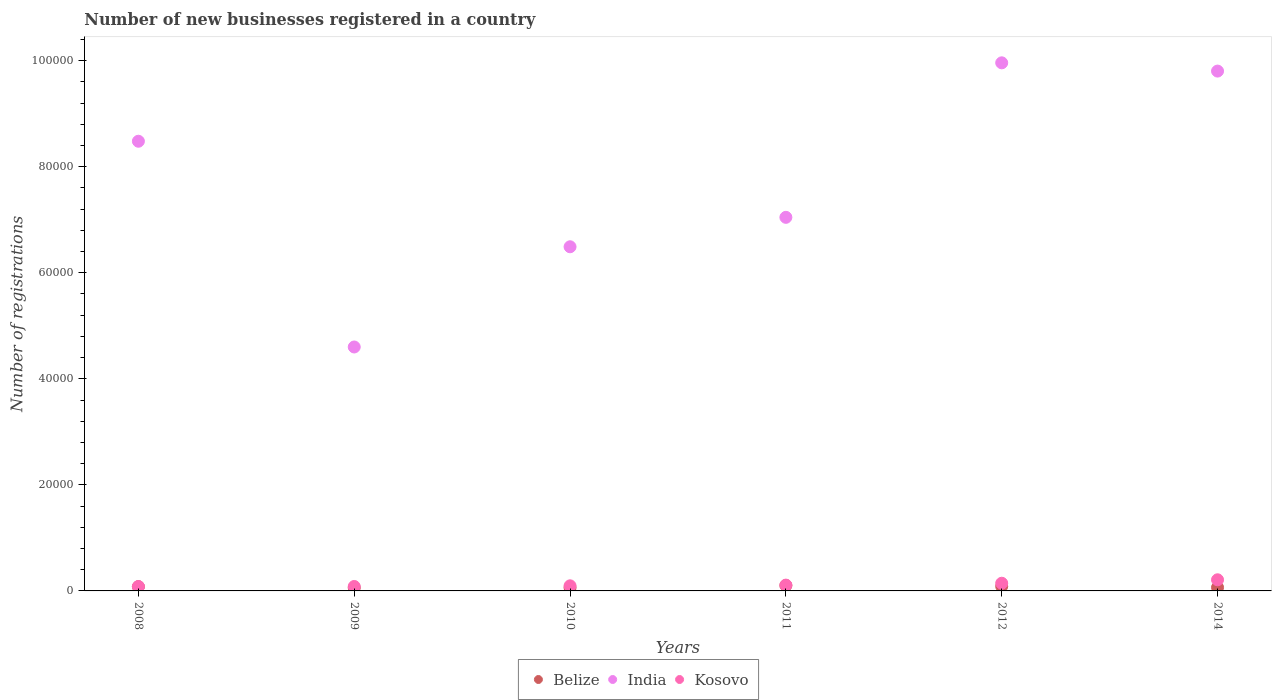What is the number of new businesses registered in India in 2012?
Provide a short and direct response. 9.96e+04. Across all years, what is the maximum number of new businesses registered in Belize?
Keep it short and to the point. 1025. Across all years, what is the minimum number of new businesses registered in India?
Offer a terse response. 4.60e+04. In which year was the number of new businesses registered in Kosovo maximum?
Keep it short and to the point. 2014. In which year was the number of new businesses registered in Kosovo minimum?
Offer a terse response. 2008. What is the total number of new businesses registered in Kosovo in the graph?
Your response must be concise. 7271. What is the difference between the number of new businesses registered in Belize in 2008 and that in 2014?
Provide a succinct answer. 146. What is the difference between the number of new businesses registered in India in 2008 and the number of new businesses registered in Belize in 2009?
Your answer should be compact. 8.42e+04. What is the average number of new businesses registered in Belize per year?
Ensure brevity in your answer.  754.17. In the year 2009, what is the difference between the number of new businesses registered in India and number of new businesses registered in Belize?
Offer a terse response. 4.54e+04. What is the ratio of the number of new businesses registered in India in 2009 to that in 2012?
Ensure brevity in your answer.  0.46. What is the difference between the highest and the second highest number of new businesses registered in Belize?
Keep it short and to the point. 163. What is the difference between the highest and the lowest number of new businesses registered in Belize?
Offer a terse response. 444. In how many years, is the number of new businesses registered in India greater than the average number of new businesses registered in India taken over all years?
Offer a very short reply. 3. Is the sum of the number of new businesses registered in Kosovo in 2008 and 2014 greater than the maximum number of new businesses registered in Belize across all years?
Your answer should be compact. Yes. How many years are there in the graph?
Your answer should be very brief. 6. Does the graph contain any zero values?
Offer a very short reply. No. What is the title of the graph?
Ensure brevity in your answer.  Number of new businesses registered in a country. What is the label or title of the Y-axis?
Make the answer very short. Number of registrations. What is the Number of registrations of Belize in 2008?
Provide a succinct answer. 801. What is the Number of registrations of India in 2008?
Ensure brevity in your answer.  8.48e+04. What is the Number of registrations of Kosovo in 2008?
Your answer should be very brief. 829. What is the Number of registrations of Belize in 2009?
Give a very brief answer. 581. What is the Number of registrations in India in 2009?
Keep it short and to the point. 4.60e+04. What is the Number of registrations in Kosovo in 2009?
Keep it short and to the point. 836. What is the Number of registrations of Belize in 2010?
Your response must be concise. 601. What is the Number of registrations in India in 2010?
Keep it short and to the point. 6.49e+04. What is the Number of registrations of Kosovo in 2010?
Offer a very short reply. 962. What is the Number of registrations of Belize in 2011?
Make the answer very short. 1025. What is the Number of registrations in India in 2011?
Give a very brief answer. 7.04e+04. What is the Number of registrations of Kosovo in 2011?
Make the answer very short. 1095. What is the Number of registrations in Belize in 2012?
Offer a terse response. 862. What is the Number of registrations in India in 2012?
Provide a short and direct response. 9.96e+04. What is the Number of registrations in Kosovo in 2012?
Keep it short and to the point. 1449. What is the Number of registrations in Belize in 2014?
Your response must be concise. 655. What is the Number of registrations of India in 2014?
Give a very brief answer. 9.80e+04. What is the Number of registrations in Kosovo in 2014?
Keep it short and to the point. 2100. Across all years, what is the maximum Number of registrations in Belize?
Make the answer very short. 1025. Across all years, what is the maximum Number of registrations of India?
Provide a succinct answer. 9.96e+04. Across all years, what is the maximum Number of registrations of Kosovo?
Your response must be concise. 2100. Across all years, what is the minimum Number of registrations in Belize?
Your response must be concise. 581. Across all years, what is the minimum Number of registrations of India?
Give a very brief answer. 4.60e+04. Across all years, what is the minimum Number of registrations of Kosovo?
Your answer should be very brief. 829. What is the total Number of registrations in Belize in the graph?
Provide a succinct answer. 4525. What is the total Number of registrations of India in the graph?
Give a very brief answer. 4.64e+05. What is the total Number of registrations of Kosovo in the graph?
Provide a short and direct response. 7271. What is the difference between the Number of registrations in Belize in 2008 and that in 2009?
Keep it short and to the point. 220. What is the difference between the Number of registrations of India in 2008 and that in 2009?
Offer a terse response. 3.88e+04. What is the difference between the Number of registrations of India in 2008 and that in 2010?
Provide a succinct answer. 1.99e+04. What is the difference between the Number of registrations in Kosovo in 2008 and that in 2010?
Offer a very short reply. -133. What is the difference between the Number of registrations of Belize in 2008 and that in 2011?
Provide a succinct answer. -224. What is the difference between the Number of registrations in India in 2008 and that in 2011?
Keep it short and to the point. 1.44e+04. What is the difference between the Number of registrations in Kosovo in 2008 and that in 2011?
Ensure brevity in your answer.  -266. What is the difference between the Number of registrations in Belize in 2008 and that in 2012?
Your response must be concise. -61. What is the difference between the Number of registrations in India in 2008 and that in 2012?
Give a very brief answer. -1.48e+04. What is the difference between the Number of registrations in Kosovo in 2008 and that in 2012?
Provide a short and direct response. -620. What is the difference between the Number of registrations in Belize in 2008 and that in 2014?
Give a very brief answer. 146. What is the difference between the Number of registrations in India in 2008 and that in 2014?
Offer a very short reply. -1.32e+04. What is the difference between the Number of registrations in Kosovo in 2008 and that in 2014?
Keep it short and to the point. -1271. What is the difference between the Number of registrations in India in 2009 and that in 2010?
Your response must be concise. -1.89e+04. What is the difference between the Number of registrations of Kosovo in 2009 and that in 2010?
Keep it short and to the point. -126. What is the difference between the Number of registrations of Belize in 2009 and that in 2011?
Offer a very short reply. -444. What is the difference between the Number of registrations in India in 2009 and that in 2011?
Your response must be concise. -2.44e+04. What is the difference between the Number of registrations of Kosovo in 2009 and that in 2011?
Provide a succinct answer. -259. What is the difference between the Number of registrations of Belize in 2009 and that in 2012?
Offer a terse response. -281. What is the difference between the Number of registrations in India in 2009 and that in 2012?
Ensure brevity in your answer.  -5.36e+04. What is the difference between the Number of registrations of Kosovo in 2009 and that in 2012?
Keep it short and to the point. -613. What is the difference between the Number of registrations of Belize in 2009 and that in 2014?
Give a very brief answer. -74. What is the difference between the Number of registrations of India in 2009 and that in 2014?
Ensure brevity in your answer.  -5.20e+04. What is the difference between the Number of registrations of Kosovo in 2009 and that in 2014?
Provide a succinct answer. -1264. What is the difference between the Number of registrations in Belize in 2010 and that in 2011?
Offer a very short reply. -424. What is the difference between the Number of registrations of India in 2010 and that in 2011?
Your response must be concise. -5550. What is the difference between the Number of registrations of Kosovo in 2010 and that in 2011?
Ensure brevity in your answer.  -133. What is the difference between the Number of registrations in Belize in 2010 and that in 2012?
Give a very brief answer. -261. What is the difference between the Number of registrations in India in 2010 and that in 2012?
Your answer should be very brief. -3.47e+04. What is the difference between the Number of registrations of Kosovo in 2010 and that in 2012?
Give a very brief answer. -487. What is the difference between the Number of registrations of Belize in 2010 and that in 2014?
Your answer should be compact. -54. What is the difference between the Number of registrations of India in 2010 and that in 2014?
Your response must be concise. -3.31e+04. What is the difference between the Number of registrations of Kosovo in 2010 and that in 2014?
Keep it short and to the point. -1138. What is the difference between the Number of registrations of Belize in 2011 and that in 2012?
Offer a very short reply. 163. What is the difference between the Number of registrations of India in 2011 and that in 2012?
Your answer should be very brief. -2.91e+04. What is the difference between the Number of registrations in Kosovo in 2011 and that in 2012?
Provide a succinct answer. -354. What is the difference between the Number of registrations in Belize in 2011 and that in 2014?
Give a very brief answer. 370. What is the difference between the Number of registrations in India in 2011 and that in 2014?
Give a very brief answer. -2.76e+04. What is the difference between the Number of registrations of Kosovo in 2011 and that in 2014?
Your answer should be compact. -1005. What is the difference between the Number of registrations in Belize in 2012 and that in 2014?
Provide a succinct answer. 207. What is the difference between the Number of registrations in India in 2012 and that in 2014?
Your answer should be compact. 1558. What is the difference between the Number of registrations in Kosovo in 2012 and that in 2014?
Give a very brief answer. -651. What is the difference between the Number of registrations of Belize in 2008 and the Number of registrations of India in 2009?
Provide a short and direct response. -4.52e+04. What is the difference between the Number of registrations in Belize in 2008 and the Number of registrations in Kosovo in 2009?
Ensure brevity in your answer.  -35. What is the difference between the Number of registrations in India in 2008 and the Number of registrations in Kosovo in 2009?
Provide a succinct answer. 8.40e+04. What is the difference between the Number of registrations of Belize in 2008 and the Number of registrations of India in 2010?
Ensure brevity in your answer.  -6.41e+04. What is the difference between the Number of registrations of Belize in 2008 and the Number of registrations of Kosovo in 2010?
Your response must be concise. -161. What is the difference between the Number of registrations in India in 2008 and the Number of registrations in Kosovo in 2010?
Make the answer very short. 8.38e+04. What is the difference between the Number of registrations of Belize in 2008 and the Number of registrations of India in 2011?
Your response must be concise. -6.96e+04. What is the difference between the Number of registrations in Belize in 2008 and the Number of registrations in Kosovo in 2011?
Give a very brief answer. -294. What is the difference between the Number of registrations in India in 2008 and the Number of registrations in Kosovo in 2011?
Provide a succinct answer. 8.37e+04. What is the difference between the Number of registrations of Belize in 2008 and the Number of registrations of India in 2012?
Your answer should be very brief. -9.88e+04. What is the difference between the Number of registrations of Belize in 2008 and the Number of registrations of Kosovo in 2012?
Give a very brief answer. -648. What is the difference between the Number of registrations in India in 2008 and the Number of registrations in Kosovo in 2012?
Ensure brevity in your answer.  8.34e+04. What is the difference between the Number of registrations of Belize in 2008 and the Number of registrations of India in 2014?
Ensure brevity in your answer.  -9.72e+04. What is the difference between the Number of registrations of Belize in 2008 and the Number of registrations of Kosovo in 2014?
Your answer should be very brief. -1299. What is the difference between the Number of registrations of India in 2008 and the Number of registrations of Kosovo in 2014?
Provide a short and direct response. 8.27e+04. What is the difference between the Number of registrations in Belize in 2009 and the Number of registrations in India in 2010?
Offer a very short reply. -6.43e+04. What is the difference between the Number of registrations in Belize in 2009 and the Number of registrations in Kosovo in 2010?
Your answer should be compact. -381. What is the difference between the Number of registrations of India in 2009 and the Number of registrations of Kosovo in 2010?
Your answer should be very brief. 4.50e+04. What is the difference between the Number of registrations in Belize in 2009 and the Number of registrations in India in 2011?
Give a very brief answer. -6.99e+04. What is the difference between the Number of registrations in Belize in 2009 and the Number of registrations in Kosovo in 2011?
Ensure brevity in your answer.  -514. What is the difference between the Number of registrations in India in 2009 and the Number of registrations in Kosovo in 2011?
Ensure brevity in your answer.  4.49e+04. What is the difference between the Number of registrations of Belize in 2009 and the Number of registrations of India in 2012?
Your response must be concise. -9.90e+04. What is the difference between the Number of registrations in Belize in 2009 and the Number of registrations in Kosovo in 2012?
Provide a succinct answer. -868. What is the difference between the Number of registrations in India in 2009 and the Number of registrations in Kosovo in 2012?
Provide a short and direct response. 4.46e+04. What is the difference between the Number of registrations in Belize in 2009 and the Number of registrations in India in 2014?
Ensure brevity in your answer.  -9.74e+04. What is the difference between the Number of registrations of Belize in 2009 and the Number of registrations of Kosovo in 2014?
Your answer should be compact. -1519. What is the difference between the Number of registrations in India in 2009 and the Number of registrations in Kosovo in 2014?
Offer a very short reply. 4.39e+04. What is the difference between the Number of registrations in Belize in 2010 and the Number of registrations in India in 2011?
Your response must be concise. -6.98e+04. What is the difference between the Number of registrations in Belize in 2010 and the Number of registrations in Kosovo in 2011?
Give a very brief answer. -494. What is the difference between the Number of registrations in India in 2010 and the Number of registrations in Kosovo in 2011?
Your response must be concise. 6.38e+04. What is the difference between the Number of registrations in Belize in 2010 and the Number of registrations in India in 2012?
Make the answer very short. -9.90e+04. What is the difference between the Number of registrations of Belize in 2010 and the Number of registrations of Kosovo in 2012?
Ensure brevity in your answer.  -848. What is the difference between the Number of registrations in India in 2010 and the Number of registrations in Kosovo in 2012?
Your answer should be compact. 6.35e+04. What is the difference between the Number of registrations of Belize in 2010 and the Number of registrations of India in 2014?
Keep it short and to the point. -9.74e+04. What is the difference between the Number of registrations in Belize in 2010 and the Number of registrations in Kosovo in 2014?
Ensure brevity in your answer.  -1499. What is the difference between the Number of registrations of India in 2010 and the Number of registrations of Kosovo in 2014?
Your response must be concise. 6.28e+04. What is the difference between the Number of registrations in Belize in 2011 and the Number of registrations in India in 2012?
Offer a very short reply. -9.86e+04. What is the difference between the Number of registrations of Belize in 2011 and the Number of registrations of Kosovo in 2012?
Ensure brevity in your answer.  -424. What is the difference between the Number of registrations of India in 2011 and the Number of registrations of Kosovo in 2012?
Offer a terse response. 6.90e+04. What is the difference between the Number of registrations in Belize in 2011 and the Number of registrations in India in 2014?
Offer a terse response. -9.70e+04. What is the difference between the Number of registrations of Belize in 2011 and the Number of registrations of Kosovo in 2014?
Your answer should be very brief. -1075. What is the difference between the Number of registrations of India in 2011 and the Number of registrations of Kosovo in 2014?
Keep it short and to the point. 6.84e+04. What is the difference between the Number of registrations in Belize in 2012 and the Number of registrations in India in 2014?
Your answer should be very brief. -9.72e+04. What is the difference between the Number of registrations in Belize in 2012 and the Number of registrations in Kosovo in 2014?
Your answer should be very brief. -1238. What is the difference between the Number of registrations in India in 2012 and the Number of registrations in Kosovo in 2014?
Give a very brief answer. 9.75e+04. What is the average Number of registrations in Belize per year?
Provide a succinct answer. 754.17. What is the average Number of registrations in India per year?
Your answer should be compact. 7.73e+04. What is the average Number of registrations in Kosovo per year?
Give a very brief answer. 1211.83. In the year 2008, what is the difference between the Number of registrations of Belize and Number of registrations of India?
Your response must be concise. -8.40e+04. In the year 2008, what is the difference between the Number of registrations in India and Number of registrations in Kosovo?
Make the answer very short. 8.40e+04. In the year 2009, what is the difference between the Number of registrations of Belize and Number of registrations of India?
Ensure brevity in your answer.  -4.54e+04. In the year 2009, what is the difference between the Number of registrations in Belize and Number of registrations in Kosovo?
Offer a very short reply. -255. In the year 2009, what is the difference between the Number of registrations in India and Number of registrations in Kosovo?
Offer a terse response. 4.52e+04. In the year 2010, what is the difference between the Number of registrations in Belize and Number of registrations in India?
Your answer should be compact. -6.43e+04. In the year 2010, what is the difference between the Number of registrations in Belize and Number of registrations in Kosovo?
Offer a terse response. -361. In the year 2010, what is the difference between the Number of registrations of India and Number of registrations of Kosovo?
Provide a succinct answer. 6.39e+04. In the year 2011, what is the difference between the Number of registrations of Belize and Number of registrations of India?
Keep it short and to the point. -6.94e+04. In the year 2011, what is the difference between the Number of registrations of Belize and Number of registrations of Kosovo?
Keep it short and to the point. -70. In the year 2011, what is the difference between the Number of registrations of India and Number of registrations of Kosovo?
Offer a very short reply. 6.94e+04. In the year 2012, what is the difference between the Number of registrations in Belize and Number of registrations in India?
Your response must be concise. -9.87e+04. In the year 2012, what is the difference between the Number of registrations of Belize and Number of registrations of Kosovo?
Your answer should be very brief. -587. In the year 2012, what is the difference between the Number of registrations of India and Number of registrations of Kosovo?
Your response must be concise. 9.81e+04. In the year 2014, what is the difference between the Number of registrations of Belize and Number of registrations of India?
Your answer should be very brief. -9.74e+04. In the year 2014, what is the difference between the Number of registrations in Belize and Number of registrations in Kosovo?
Ensure brevity in your answer.  -1445. In the year 2014, what is the difference between the Number of registrations in India and Number of registrations in Kosovo?
Make the answer very short. 9.59e+04. What is the ratio of the Number of registrations of Belize in 2008 to that in 2009?
Make the answer very short. 1.38. What is the ratio of the Number of registrations in India in 2008 to that in 2009?
Keep it short and to the point. 1.84. What is the ratio of the Number of registrations in Belize in 2008 to that in 2010?
Provide a succinct answer. 1.33. What is the ratio of the Number of registrations in India in 2008 to that in 2010?
Ensure brevity in your answer.  1.31. What is the ratio of the Number of registrations of Kosovo in 2008 to that in 2010?
Offer a terse response. 0.86. What is the ratio of the Number of registrations in Belize in 2008 to that in 2011?
Your answer should be very brief. 0.78. What is the ratio of the Number of registrations in India in 2008 to that in 2011?
Offer a very short reply. 1.2. What is the ratio of the Number of registrations in Kosovo in 2008 to that in 2011?
Your response must be concise. 0.76. What is the ratio of the Number of registrations in Belize in 2008 to that in 2012?
Provide a succinct answer. 0.93. What is the ratio of the Number of registrations of India in 2008 to that in 2012?
Offer a very short reply. 0.85. What is the ratio of the Number of registrations in Kosovo in 2008 to that in 2012?
Keep it short and to the point. 0.57. What is the ratio of the Number of registrations in Belize in 2008 to that in 2014?
Provide a succinct answer. 1.22. What is the ratio of the Number of registrations in India in 2008 to that in 2014?
Provide a short and direct response. 0.87. What is the ratio of the Number of registrations of Kosovo in 2008 to that in 2014?
Ensure brevity in your answer.  0.39. What is the ratio of the Number of registrations of Belize in 2009 to that in 2010?
Provide a short and direct response. 0.97. What is the ratio of the Number of registrations in India in 2009 to that in 2010?
Make the answer very short. 0.71. What is the ratio of the Number of registrations of Kosovo in 2009 to that in 2010?
Ensure brevity in your answer.  0.87. What is the ratio of the Number of registrations of Belize in 2009 to that in 2011?
Make the answer very short. 0.57. What is the ratio of the Number of registrations in India in 2009 to that in 2011?
Provide a short and direct response. 0.65. What is the ratio of the Number of registrations of Kosovo in 2009 to that in 2011?
Offer a very short reply. 0.76. What is the ratio of the Number of registrations of Belize in 2009 to that in 2012?
Your response must be concise. 0.67. What is the ratio of the Number of registrations in India in 2009 to that in 2012?
Ensure brevity in your answer.  0.46. What is the ratio of the Number of registrations in Kosovo in 2009 to that in 2012?
Provide a short and direct response. 0.58. What is the ratio of the Number of registrations of Belize in 2009 to that in 2014?
Make the answer very short. 0.89. What is the ratio of the Number of registrations of India in 2009 to that in 2014?
Ensure brevity in your answer.  0.47. What is the ratio of the Number of registrations of Kosovo in 2009 to that in 2014?
Your response must be concise. 0.4. What is the ratio of the Number of registrations of Belize in 2010 to that in 2011?
Your answer should be compact. 0.59. What is the ratio of the Number of registrations of India in 2010 to that in 2011?
Offer a terse response. 0.92. What is the ratio of the Number of registrations in Kosovo in 2010 to that in 2011?
Offer a terse response. 0.88. What is the ratio of the Number of registrations in Belize in 2010 to that in 2012?
Your answer should be compact. 0.7. What is the ratio of the Number of registrations in India in 2010 to that in 2012?
Provide a short and direct response. 0.65. What is the ratio of the Number of registrations in Kosovo in 2010 to that in 2012?
Your answer should be compact. 0.66. What is the ratio of the Number of registrations in Belize in 2010 to that in 2014?
Your answer should be compact. 0.92. What is the ratio of the Number of registrations of India in 2010 to that in 2014?
Provide a succinct answer. 0.66. What is the ratio of the Number of registrations in Kosovo in 2010 to that in 2014?
Provide a short and direct response. 0.46. What is the ratio of the Number of registrations of Belize in 2011 to that in 2012?
Ensure brevity in your answer.  1.19. What is the ratio of the Number of registrations in India in 2011 to that in 2012?
Your answer should be very brief. 0.71. What is the ratio of the Number of registrations of Kosovo in 2011 to that in 2012?
Keep it short and to the point. 0.76. What is the ratio of the Number of registrations of Belize in 2011 to that in 2014?
Offer a very short reply. 1.56. What is the ratio of the Number of registrations in India in 2011 to that in 2014?
Ensure brevity in your answer.  0.72. What is the ratio of the Number of registrations of Kosovo in 2011 to that in 2014?
Provide a short and direct response. 0.52. What is the ratio of the Number of registrations in Belize in 2012 to that in 2014?
Your response must be concise. 1.32. What is the ratio of the Number of registrations of India in 2012 to that in 2014?
Give a very brief answer. 1.02. What is the ratio of the Number of registrations in Kosovo in 2012 to that in 2014?
Provide a short and direct response. 0.69. What is the difference between the highest and the second highest Number of registrations of Belize?
Make the answer very short. 163. What is the difference between the highest and the second highest Number of registrations in India?
Provide a short and direct response. 1558. What is the difference between the highest and the second highest Number of registrations of Kosovo?
Provide a succinct answer. 651. What is the difference between the highest and the lowest Number of registrations of Belize?
Your response must be concise. 444. What is the difference between the highest and the lowest Number of registrations in India?
Offer a terse response. 5.36e+04. What is the difference between the highest and the lowest Number of registrations in Kosovo?
Ensure brevity in your answer.  1271. 